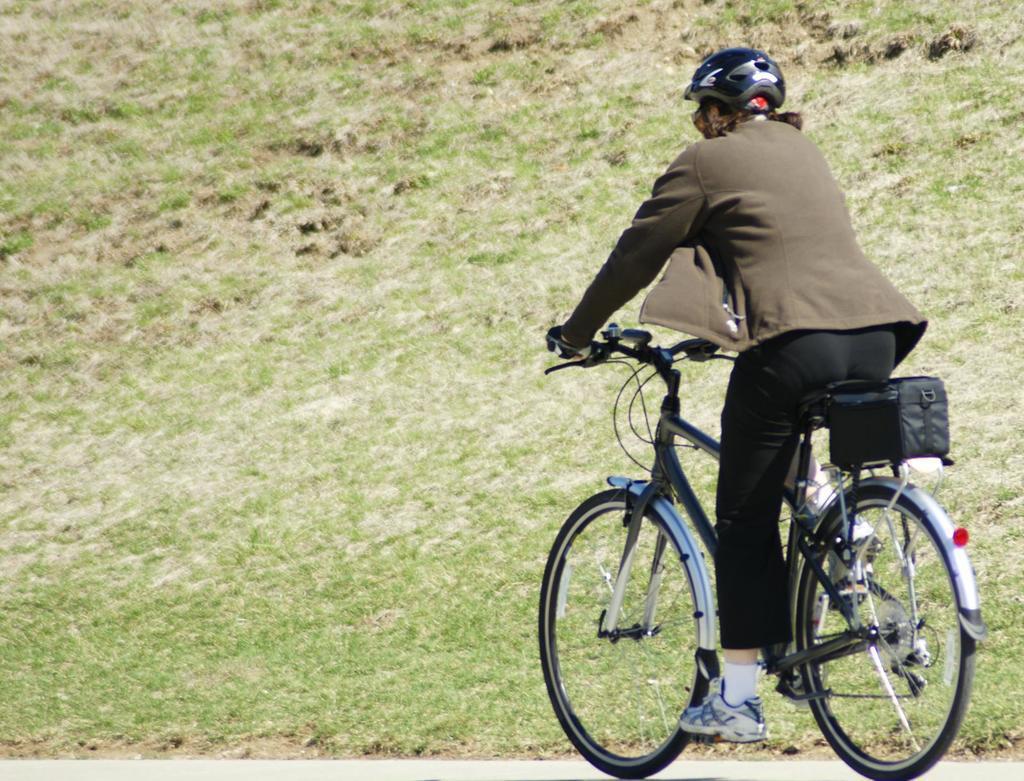Describe this image in one or two sentences. This person is riding a bicycle by wearing helmet, socks, shoes. Backside of bicycle there is a bag. Background there is a grassy land. 